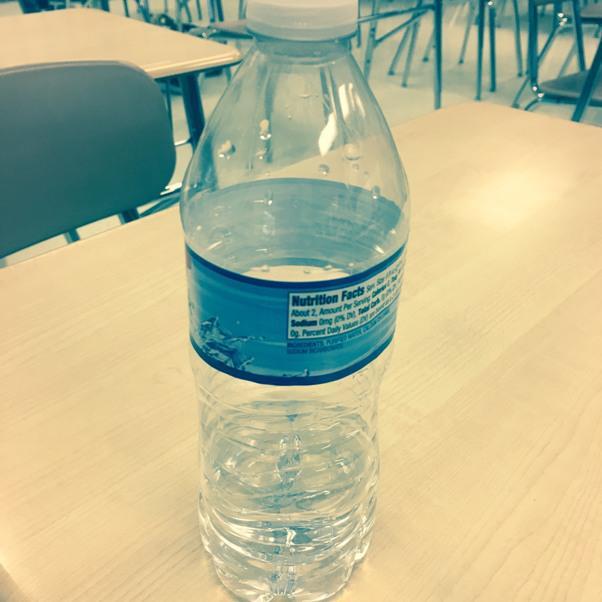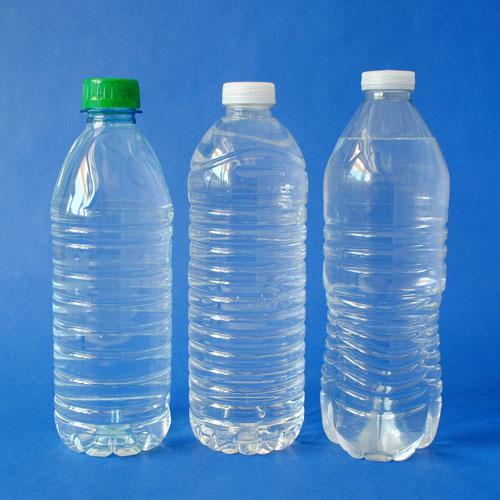The first image is the image on the left, the second image is the image on the right. For the images shown, is this caption "There are three or more plastic water bottles in total." true? Answer yes or no. Yes. The first image is the image on the left, the second image is the image on the right. For the images shown, is this caption "The combined images include an open-topped glass of water and no more than two plastic water bottles." true? Answer yes or no. No. 